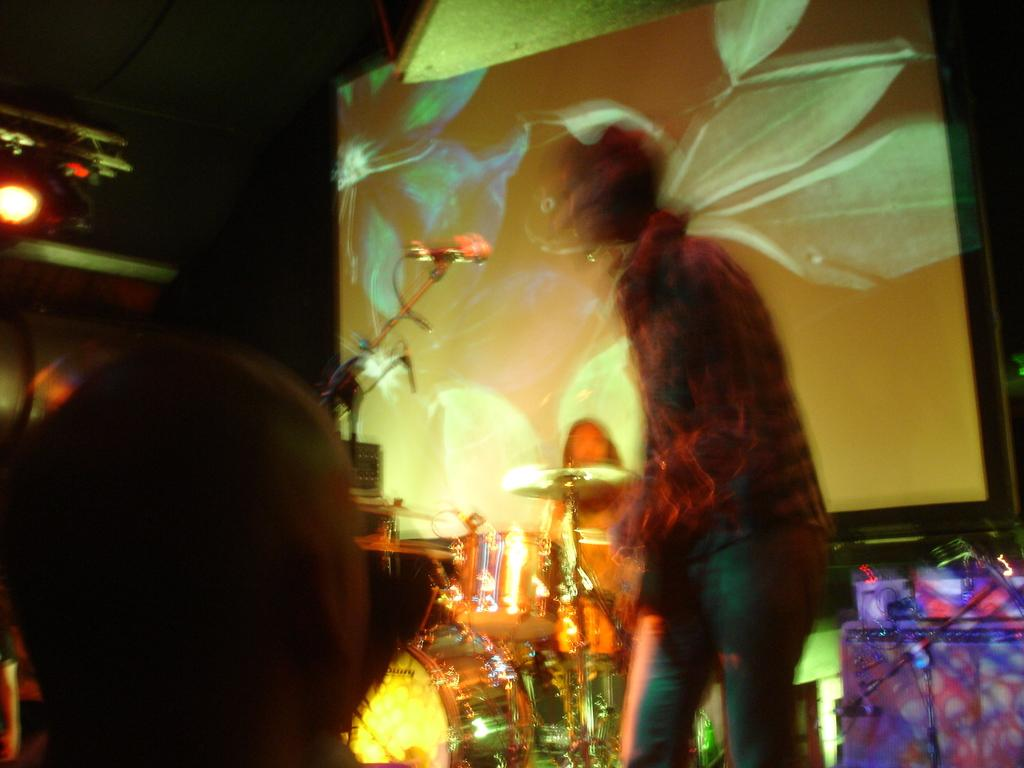Who or what is present in the image? There are people in the image. What are the people doing in the image? They are playing musical instruments. What equipment is used for amplifying sound in the image? A microphone is present in the image. What can be seen in the background of the image? There is a screen and lights in the background of the image. What type of lizards can be seen climbing on the screen in the image? There are no lizards present in the image; it features people playing musical instruments with a microphone and a screen in the background. 